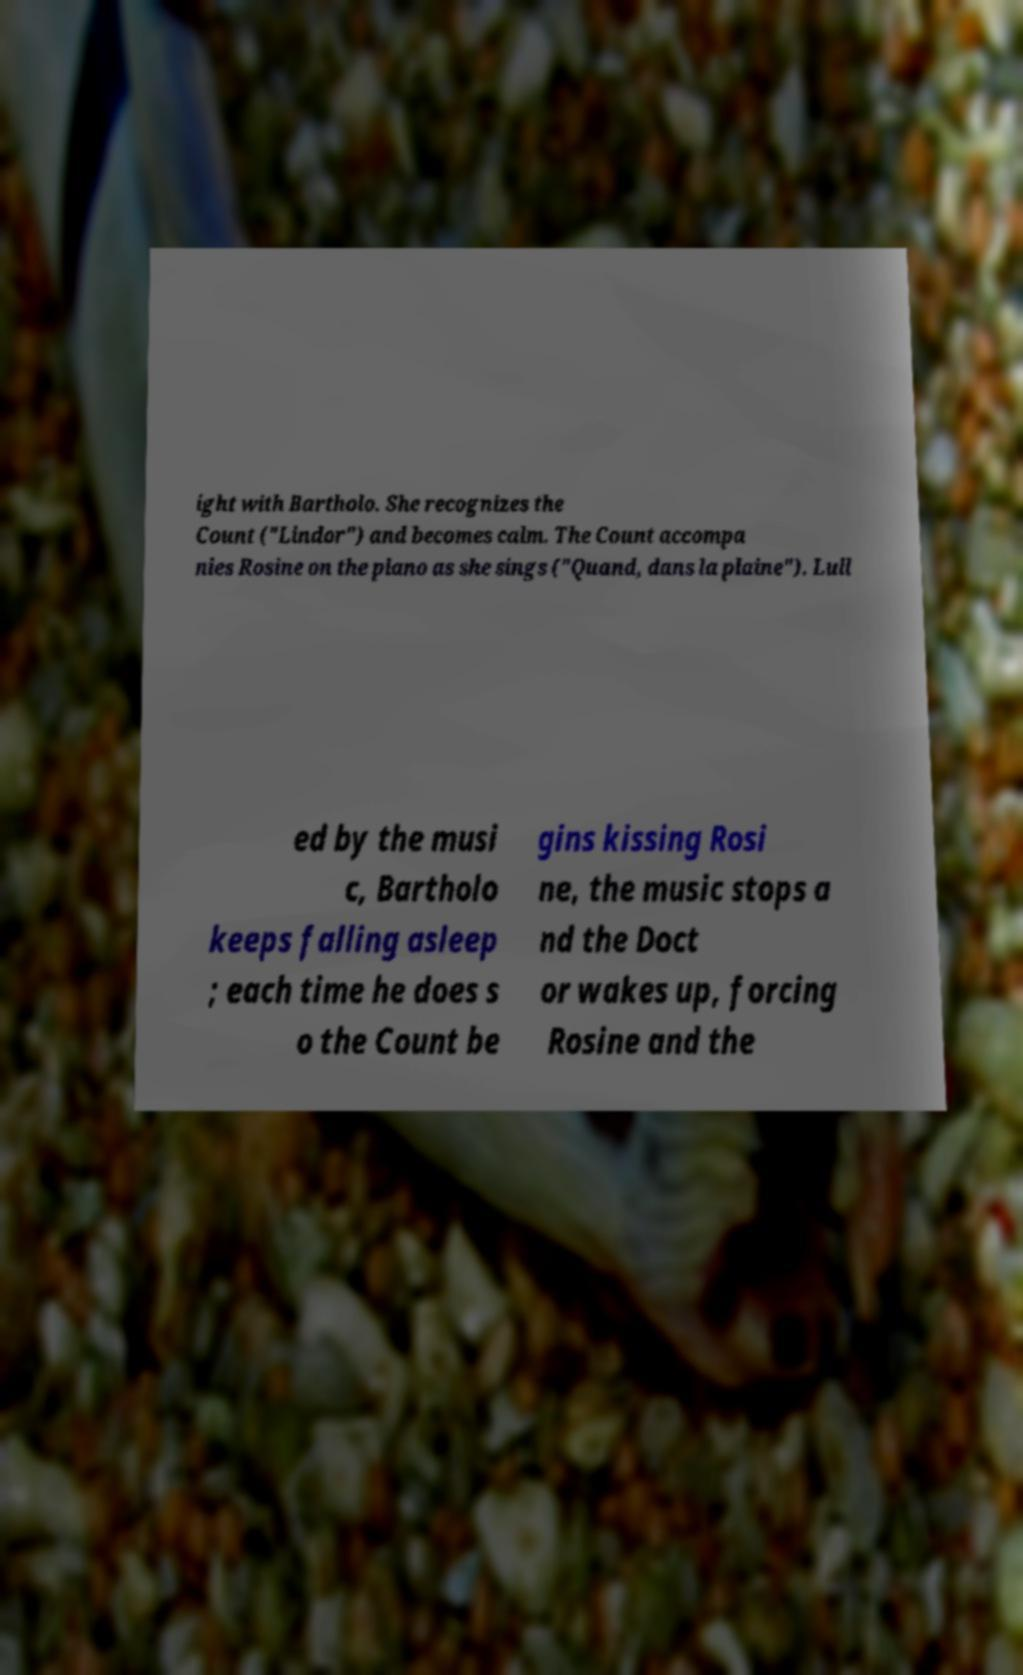Please identify and transcribe the text found in this image. ight with Bartholo. She recognizes the Count ("Lindor") and becomes calm. The Count accompa nies Rosine on the piano as she sings ("Quand, dans la plaine"). Lull ed by the musi c, Bartholo keeps falling asleep ; each time he does s o the Count be gins kissing Rosi ne, the music stops a nd the Doct or wakes up, forcing Rosine and the 